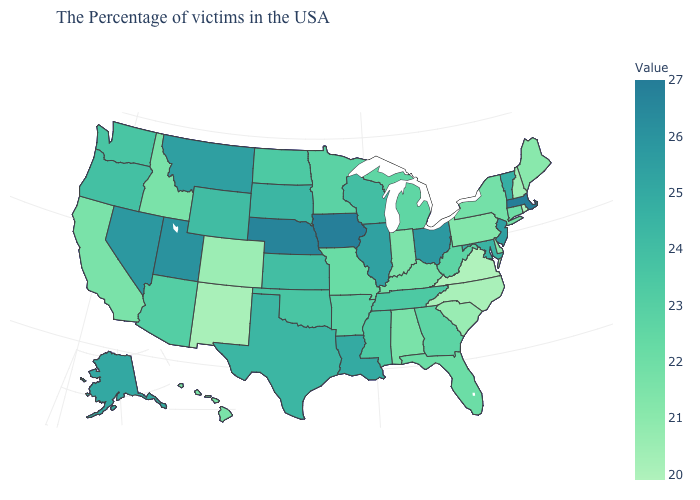Does Vermont have a higher value than North Dakota?
Answer briefly. Yes. Which states have the highest value in the USA?
Answer briefly. Massachusetts. Does Ohio have the lowest value in the MidWest?
Be succinct. No. Among the states that border Louisiana , which have the highest value?
Be succinct. Texas. Does Iowa have the highest value in the MidWest?
Short answer required. Yes. Which states have the lowest value in the USA?
Be succinct. Rhode Island, Virginia. 